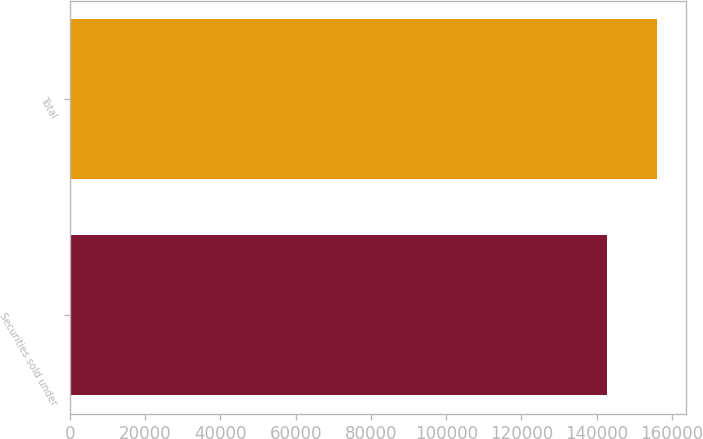<chart> <loc_0><loc_0><loc_500><loc_500><bar_chart><fcel>Securities sold under<fcel>Total<nl><fcel>142646<fcel>155951<nl></chart> 